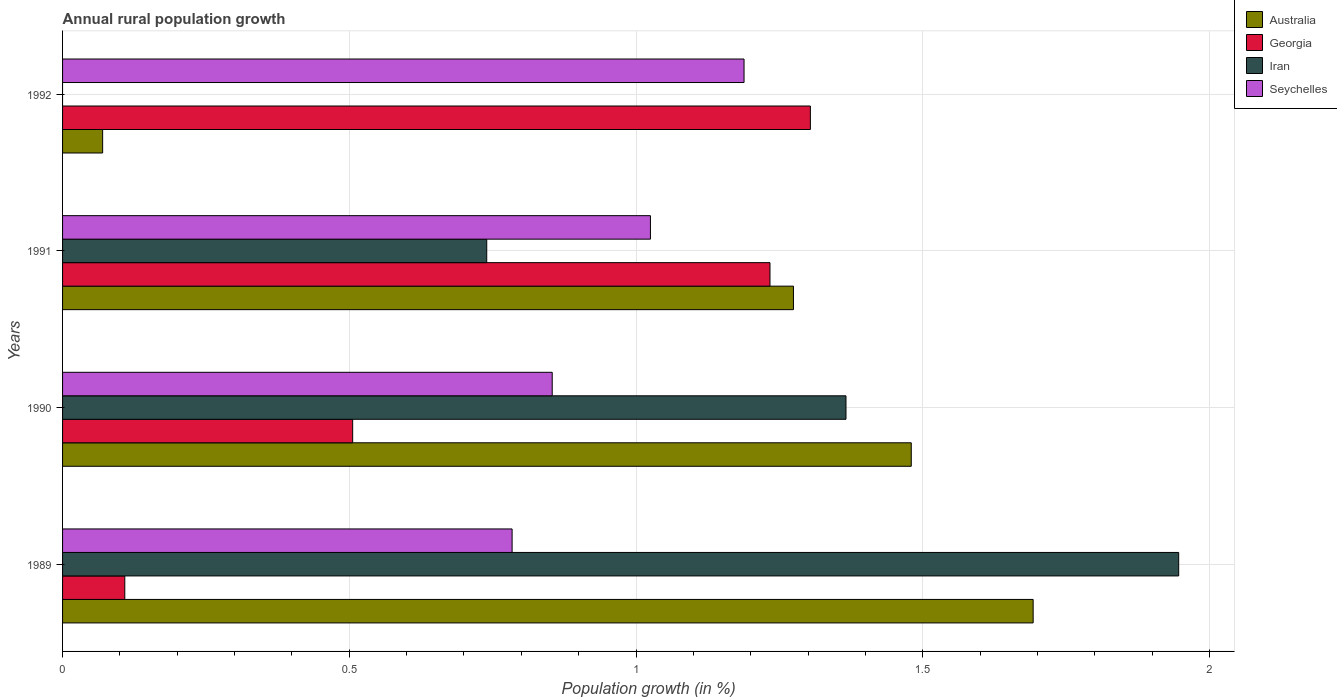How many different coloured bars are there?
Keep it short and to the point. 4. How many groups of bars are there?
Ensure brevity in your answer.  4. Are the number of bars per tick equal to the number of legend labels?
Your answer should be very brief. No. Are the number of bars on each tick of the Y-axis equal?
Ensure brevity in your answer.  No. How many bars are there on the 4th tick from the bottom?
Provide a succinct answer. 3. What is the label of the 1st group of bars from the top?
Your answer should be very brief. 1992. In how many cases, is the number of bars for a given year not equal to the number of legend labels?
Keep it short and to the point. 1. What is the percentage of rural population growth in Seychelles in 1991?
Ensure brevity in your answer.  1.03. Across all years, what is the maximum percentage of rural population growth in Iran?
Provide a succinct answer. 1.95. Across all years, what is the minimum percentage of rural population growth in Iran?
Your answer should be compact. 0. In which year was the percentage of rural population growth in Seychelles maximum?
Your response must be concise. 1992. What is the total percentage of rural population growth in Australia in the graph?
Offer a very short reply. 4.52. What is the difference between the percentage of rural population growth in Australia in 1990 and that in 1992?
Give a very brief answer. 1.41. What is the difference between the percentage of rural population growth in Iran in 1992 and the percentage of rural population growth in Georgia in 1991?
Keep it short and to the point. -1.23. What is the average percentage of rural population growth in Iran per year?
Your answer should be compact. 1.01. In the year 1991, what is the difference between the percentage of rural population growth in Iran and percentage of rural population growth in Georgia?
Your answer should be compact. -0.49. In how many years, is the percentage of rural population growth in Australia greater than 1.7 %?
Provide a short and direct response. 0. What is the ratio of the percentage of rural population growth in Seychelles in 1989 to that in 1991?
Offer a very short reply. 0.76. Is the percentage of rural population growth in Georgia in 1991 less than that in 1992?
Ensure brevity in your answer.  Yes. What is the difference between the highest and the second highest percentage of rural population growth in Georgia?
Ensure brevity in your answer.  0.07. What is the difference between the highest and the lowest percentage of rural population growth in Australia?
Make the answer very short. 1.62. In how many years, is the percentage of rural population growth in Georgia greater than the average percentage of rural population growth in Georgia taken over all years?
Provide a short and direct response. 2. Is the sum of the percentage of rural population growth in Australia in 1989 and 1990 greater than the maximum percentage of rural population growth in Georgia across all years?
Your answer should be compact. Yes. Is it the case that in every year, the sum of the percentage of rural population growth in Iran and percentage of rural population growth in Seychelles is greater than the sum of percentage of rural population growth in Australia and percentage of rural population growth in Georgia?
Provide a short and direct response. Yes. Are all the bars in the graph horizontal?
Give a very brief answer. Yes. How many years are there in the graph?
Your answer should be compact. 4. What is the difference between two consecutive major ticks on the X-axis?
Your answer should be compact. 0.5. Does the graph contain any zero values?
Your answer should be compact. Yes. Does the graph contain grids?
Your response must be concise. Yes. How many legend labels are there?
Your answer should be compact. 4. How are the legend labels stacked?
Your answer should be compact. Vertical. What is the title of the graph?
Ensure brevity in your answer.  Annual rural population growth. Does "Isle of Man" appear as one of the legend labels in the graph?
Your answer should be very brief. No. What is the label or title of the X-axis?
Make the answer very short. Population growth (in %). What is the label or title of the Y-axis?
Give a very brief answer. Years. What is the Population growth (in %) of Australia in 1989?
Make the answer very short. 1.69. What is the Population growth (in %) of Georgia in 1989?
Your response must be concise. 0.11. What is the Population growth (in %) of Iran in 1989?
Offer a terse response. 1.95. What is the Population growth (in %) of Seychelles in 1989?
Provide a succinct answer. 0.78. What is the Population growth (in %) in Australia in 1990?
Offer a terse response. 1.48. What is the Population growth (in %) in Georgia in 1990?
Ensure brevity in your answer.  0.51. What is the Population growth (in %) in Iran in 1990?
Make the answer very short. 1.37. What is the Population growth (in %) in Seychelles in 1990?
Make the answer very short. 0.85. What is the Population growth (in %) in Australia in 1991?
Offer a terse response. 1.27. What is the Population growth (in %) in Georgia in 1991?
Provide a succinct answer. 1.23. What is the Population growth (in %) in Iran in 1991?
Give a very brief answer. 0.74. What is the Population growth (in %) of Seychelles in 1991?
Keep it short and to the point. 1.03. What is the Population growth (in %) in Australia in 1992?
Ensure brevity in your answer.  0.07. What is the Population growth (in %) of Georgia in 1992?
Offer a terse response. 1.3. What is the Population growth (in %) of Seychelles in 1992?
Keep it short and to the point. 1.19. Across all years, what is the maximum Population growth (in %) of Australia?
Your answer should be compact. 1.69. Across all years, what is the maximum Population growth (in %) in Georgia?
Make the answer very short. 1.3. Across all years, what is the maximum Population growth (in %) of Iran?
Offer a very short reply. 1.95. Across all years, what is the maximum Population growth (in %) of Seychelles?
Your answer should be compact. 1.19. Across all years, what is the minimum Population growth (in %) of Australia?
Your answer should be very brief. 0.07. Across all years, what is the minimum Population growth (in %) in Georgia?
Your response must be concise. 0.11. Across all years, what is the minimum Population growth (in %) of Seychelles?
Offer a terse response. 0.78. What is the total Population growth (in %) in Australia in the graph?
Make the answer very short. 4.52. What is the total Population growth (in %) in Georgia in the graph?
Ensure brevity in your answer.  3.15. What is the total Population growth (in %) of Iran in the graph?
Your answer should be very brief. 4.05. What is the total Population growth (in %) of Seychelles in the graph?
Ensure brevity in your answer.  3.85. What is the difference between the Population growth (in %) in Australia in 1989 and that in 1990?
Offer a very short reply. 0.21. What is the difference between the Population growth (in %) of Georgia in 1989 and that in 1990?
Your answer should be very brief. -0.4. What is the difference between the Population growth (in %) of Iran in 1989 and that in 1990?
Your answer should be compact. 0.58. What is the difference between the Population growth (in %) of Seychelles in 1989 and that in 1990?
Provide a short and direct response. -0.07. What is the difference between the Population growth (in %) of Australia in 1989 and that in 1991?
Make the answer very short. 0.42. What is the difference between the Population growth (in %) of Georgia in 1989 and that in 1991?
Your response must be concise. -1.13. What is the difference between the Population growth (in %) of Iran in 1989 and that in 1991?
Provide a succinct answer. 1.21. What is the difference between the Population growth (in %) of Seychelles in 1989 and that in 1991?
Provide a short and direct response. -0.24. What is the difference between the Population growth (in %) of Australia in 1989 and that in 1992?
Offer a terse response. 1.62. What is the difference between the Population growth (in %) of Georgia in 1989 and that in 1992?
Your response must be concise. -1.2. What is the difference between the Population growth (in %) in Seychelles in 1989 and that in 1992?
Keep it short and to the point. -0.4. What is the difference between the Population growth (in %) in Australia in 1990 and that in 1991?
Ensure brevity in your answer.  0.21. What is the difference between the Population growth (in %) of Georgia in 1990 and that in 1991?
Your answer should be very brief. -0.73. What is the difference between the Population growth (in %) of Iran in 1990 and that in 1991?
Your answer should be compact. 0.63. What is the difference between the Population growth (in %) of Seychelles in 1990 and that in 1991?
Offer a terse response. -0.17. What is the difference between the Population growth (in %) in Australia in 1990 and that in 1992?
Give a very brief answer. 1.41. What is the difference between the Population growth (in %) of Georgia in 1990 and that in 1992?
Keep it short and to the point. -0.8. What is the difference between the Population growth (in %) of Seychelles in 1990 and that in 1992?
Your answer should be compact. -0.33. What is the difference between the Population growth (in %) in Australia in 1991 and that in 1992?
Provide a succinct answer. 1.2. What is the difference between the Population growth (in %) of Georgia in 1991 and that in 1992?
Keep it short and to the point. -0.07. What is the difference between the Population growth (in %) in Seychelles in 1991 and that in 1992?
Your answer should be compact. -0.16. What is the difference between the Population growth (in %) in Australia in 1989 and the Population growth (in %) in Georgia in 1990?
Provide a succinct answer. 1.19. What is the difference between the Population growth (in %) in Australia in 1989 and the Population growth (in %) in Iran in 1990?
Give a very brief answer. 0.33. What is the difference between the Population growth (in %) in Australia in 1989 and the Population growth (in %) in Seychelles in 1990?
Offer a terse response. 0.84. What is the difference between the Population growth (in %) in Georgia in 1989 and the Population growth (in %) in Iran in 1990?
Provide a succinct answer. -1.26. What is the difference between the Population growth (in %) of Georgia in 1989 and the Population growth (in %) of Seychelles in 1990?
Ensure brevity in your answer.  -0.75. What is the difference between the Population growth (in %) of Iran in 1989 and the Population growth (in %) of Seychelles in 1990?
Your answer should be very brief. 1.09. What is the difference between the Population growth (in %) of Australia in 1989 and the Population growth (in %) of Georgia in 1991?
Your response must be concise. 0.46. What is the difference between the Population growth (in %) of Australia in 1989 and the Population growth (in %) of Iran in 1991?
Provide a succinct answer. 0.95. What is the difference between the Population growth (in %) of Australia in 1989 and the Population growth (in %) of Seychelles in 1991?
Offer a very short reply. 0.67. What is the difference between the Population growth (in %) in Georgia in 1989 and the Population growth (in %) in Iran in 1991?
Offer a terse response. -0.63. What is the difference between the Population growth (in %) in Georgia in 1989 and the Population growth (in %) in Seychelles in 1991?
Give a very brief answer. -0.92. What is the difference between the Population growth (in %) of Iran in 1989 and the Population growth (in %) of Seychelles in 1991?
Give a very brief answer. 0.92. What is the difference between the Population growth (in %) in Australia in 1989 and the Population growth (in %) in Georgia in 1992?
Provide a short and direct response. 0.39. What is the difference between the Population growth (in %) of Australia in 1989 and the Population growth (in %) of Seychelles in 1992?
Offer a terse response. 0.5. What is the difference between the Population growth (in %) of Georgia in 1989 and the Population growth (in %) of Seychelles in 1992?
Ensure brevity in your answer.  -1.08. What is the difference between the Population growth (in %) in Iran in 1989 and the Population growth (in %) in Seychelles in 1992?
Your answer should be compact. 0.76. What is the difference between the Population growth (in %) of Australia in 1990 and the Population growth (in %) of Georgia in 1991?
Offer a terse response. 0.25. What is the difference between the Population growth (in %) in Australia in 1990 and the Population growth (in %) in Iran in 1991?
Your answer should be compact. 0.74. What is the difference between the Population growth (in %) of Australia in 1990 and the Population growth (in %) of Seychelles in 1991?
Keep it short and to the point. 0.45. What is the difference between the Population growth (in %) of Georgia in 1990 and the Population growth (in %) of Iran in 1991?
Make the answer very short. -0.23. What is the difference between the Population growth (in %) in Georgia in 1990 and the Population growth (in %) in Seychelles in 1991?
Your response must be concise. -0.52. What is the difference between the Population growth (in %) in Iran in 1990 and the Population growth (in %) in Seychelles in 1991?
Offer a terse response. 0.34. What is the difference between the Population growth (in %) in Australia in 1990 and the Population growth (in %) in Georgia in 1992?
Your answer should be very brief. 0.18. What is the difference between the Population growth (in %) in Australia in 1990 and the Population growth (in %) in Seychelles in 1992?
Keep it short and to the point. 0.29. What is the difference between the Population growth (in %) of Georgia in 1990 and the Population growth (in %) of Seychelles in 1992?
Make the answer very short. -0.68. What is the difference between the Population growth (in %) in Iran in 1990 and the Population growth (in %) in Seychelles in 1992?
Your answer should be very brief. 0.18. What is the difference between the Population growth (in %) of Australia in 1991 and the Population growth (in %) of Georgia in 1992?
Your response must be concise. -0.03. What is the difference between the Population growth (in %) of Australia in 1991 and the Population growth (in %) of Seychelles in 1992?
Provide a succinct answer. 0.09. What is the difference between the Population growth (in %) in Georgia in 1991 and the Population growth (in %) in Seychelles in 1992?
Offer a very short reply. 0.05. What is the difference between the Population growth (in %) in Iran in 1991 and the Population growth (in %) in Seychelles in 1992?
Offer a terse response. -0.45. What is the average Population growth (in %) in Australia per year?
Your answer should be very brief. 1.13. What is the average Population growth (in %) in Georgia per year?
Keep it short and to the point. 0.79. What is the average Population growth (in %) of Seychelles per year?
Your answer should be compact. 0.96. In the year 1989, what is the difference between the Population growth (in %) of Australia and Population growth (in %) of Georgia?
Keep it short and to the point. 1.58. In the year 1989, what is the difference between the Population growth (in %) of Australia and Population growth (in %) of Iran?
Keep it short and to the point. -0.25. In the year 1989, what is the difference between the Population growth (in %) in Australia and Population growth (in %) in Seychelles?
Your response must be concise. 0.91. In the year 1989, what is the difference between the Population growth (in %) in Georgia and Population growth (in %) in Iran?
Give a very brief answer. -1.84. In the year 1989, what is the difference between the Population growth (in %) in Georgia and Population growth (in %) in Seychelles?
Ensure brevity in your answer.  -0.68. In the year 1989, what is the difference between the Population growth (in %) of Iran and Population growth (in %) of Seychelles?
Make the answer very short. 1.16. In the year 1990, what is the difference between the Population growth (in %) of Australia and Population growth (in %) of Georgia?
Provide a succinct answer. 0.97. In the year 1990, what is the difference between the Population growth (in %) of Australia and Population growth (in %) of Iran?
Offer a very short reply. 0.11. In the year 1990, what is the difference between the Population growth (in %) of Australia and Population growth (in %) of Seychelles?
Offer a very short reply. 0.63. In the year 1990, what is the difference between the Population growth (in %) of Georgia and Population growth (in %) of Iran?
Offer a terse response. -0.86. In the year 1990, what is the difference between the Population growth (in %) in Georgia and Population growth (in %) in Seychelles?
Provide a short and direct response. -0.35. In the year 1990, what is the difference between the Population growth (in %) of Iran and Population growth (in %) of Seychelles?
Make the answer very short. 0.51. In the year 1991, what is the difference between the Population growth (in %) of Australia and Population growth (in %) of Georgia?
Provide a short and direct response. 0.04. In the year 1991, what is the difference between the Population growth (in %) of Australia and Population growth (in %) of Iran?
Your response must be concise. 0.53. In the year 1991, what is the difference between the Population growth (in %) in Australia and Population growth (in %) in Seychelles?
Offer a terse response. 0.25. In the year 1991, what is the difference between the Population growth (in %) of Georgia and Population growth (in %) of Iran?
Make the answer very short. 0.49. In the year 1991, what is the difference between the Population growth (in %) of Georgia and Population growth (in %) of Seychelles?
Provide a succinct answer. 0.21. In the year 1991, what is the difference between the Population growth (in %) of Iran and Population growth (in %) of Seychelles?
Provide a succinct answer. -0.29. In the year 1992, what is the difference between the Population growth (in %) in Australia and Population growth (in %) in Georgia?
Your answer should be compact. -1.23. In the year 1992, what is the difference between the Population growth (in %) of Australia and Population growth (in %) of Seychelles?
Provide a short and direct response. -1.12. In the year 1992, what is the difference between the Population growth (in %) of Georgia and Population growth (in %) of Seychelles?
Your answer should be compact. 0.12. What is the ratio of the Population growth (in %) of Australia in 1989 to that in 1990?
Your answer should be compact. 1.14. What is the ratio of the Population growth (in %) of Georgia in 1989 to that in 1990?
Provide a short and direct response. 0.21. What is the ratio of the Population growth (in %) of Iran in 1989 to that in 1990?
Your answer should be compact. 1.42. What is the ratio of the Population growth (in %) of Seychelles in 1989 to that in 1990?
Offer a terse response. 0.92. What is the ratio of the Population growth (in %) of Australia in 1989 to that in 1991?
Give a very brief answer. 1.33. What is the ratio of the Population growth (in %) of Georgia in 1989 to that in 1991?
Ensure brevity in your answer.  0.09. What is the ratio of the Population growth (in %) in Iran in 1989 to that in 1991?
Your answer should be compact. 2.63. What is the ratio of the Population growth (in %) of Seychelles in 1989 to that in 1991?
Keep it short and to the point. 0.76. What is the ratio of the Population growth (in %) of Australia in 1989 to that in 1992?
Your answer should be compact. 24.22. What is the ratio of the Population growth (in %) of Georgia in 1989 to that in 1992?
Your response must be concise. 0.08. What is the ratio of the Population growth (in %) of Seychelles in 1989 to that in 1992?
Offer a terse response. 0.66. What is the ratio of the Population growth (in %) in Australia in 1990 to that in 1991?
Your answer should be very brief. 1.16. What is the ratio of the Population growth (in %) in Georgia in 1990 to that in 1991?
Your answer should be compact. 0.41. What is the ratio of the Population growth (in %) in Iran in 1990 to that in 1991?
Provide a succinct answer. 1.85. What is the ratio of the Population growth (in %) of Seychelles in 1990 to that in 1991?
Your answer should be compact. 0.83. What is the ratio of the Population growth (in %) in Australia in 1990 to that in 1992?
Your answer should be compact. 21.18. What is the ratio of the Population growth (in %) in Georgia in 1990 to that in 1992?
Provide a succinct answer. 0.39. What is the ratio of the Population growth (in %) in Seychelles in 1990 to that in 1992?
Ensure brevity in your answer.  0.72. What is the ratio of the Population growth (in %) of Australia in 1991 to that in 1992?
Provide a succinct answer. 18.24. What is the ratio of the Population growth (in %) in Georgia in 1991 to that in 1992?
Provide a succinct answer. 0.95. What is the ratio of the Population growth (in %) of Seychelles in 1991 to that in 1992?
Offer a very short reply. 0.86. What is the difference between the highest and the second highest Population growth (in %) in Australia?
Keep it short and to the point. 0.21. What is the difference between the highest and the second highest Population growth (in %) of Georgia?
Provide a short and direct response. 0.07. What is the difference between the highest and the second highest Population growth (in %) of Iran?
Your answer should be very brief. 0.58. What is the difference between the highest and the second highest Population growth (in %) in Seychelles?
Your answer should be compact. 0.16. What is the difference between the highest and the lowest Population growth (in %) in Australia?
Provide a short and direct response. 1.62. What is the difference between the highest and the lowest Population growth (in %) of Georgia?
Provide a short and direct response. 1.2. What is the difference between the highest and the lowest Population growth (in %) in Iran?
Your answer should be compact. 1.95. What is the difference between the highest and the lowest Population growth (in %) of Seychelles?
Keep it short and to the point. 0.4. 